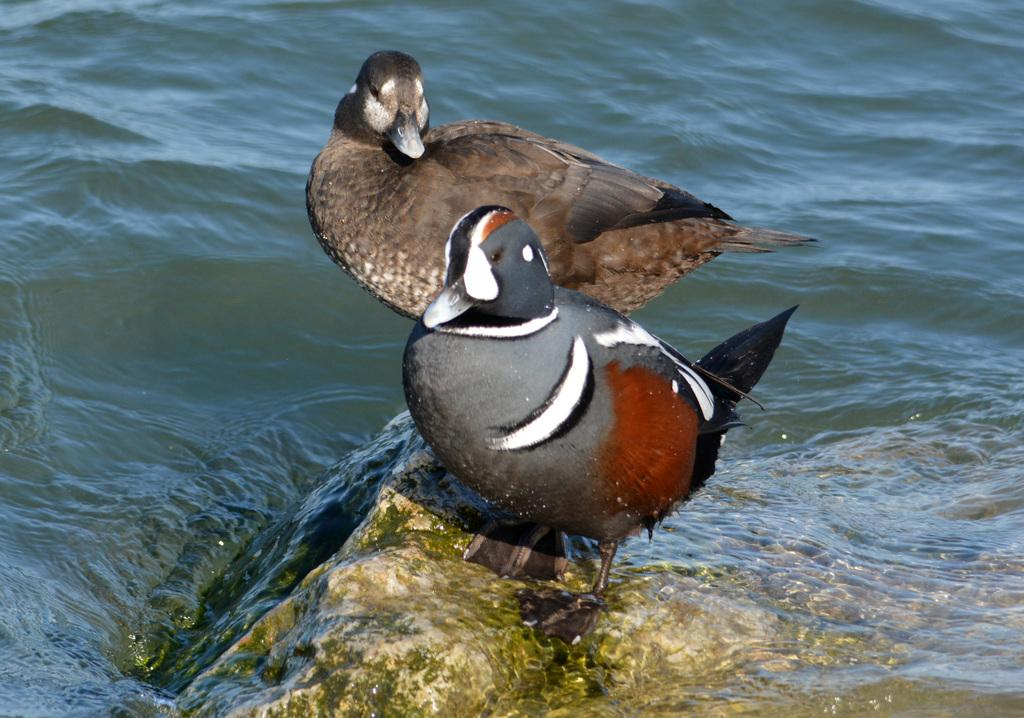How many birds are in the image? There are two birds in the image. Where are the birds located? The birds are on a rock. What can be seen in the background of the image? There is water visible in the background of the image. What might the water be part of? The water might be in a lake. Where is the nut store located in the image? There is no nut store present in the image. What type of lunchroom can be seen in the image? There is no lunchroom present in the image. 